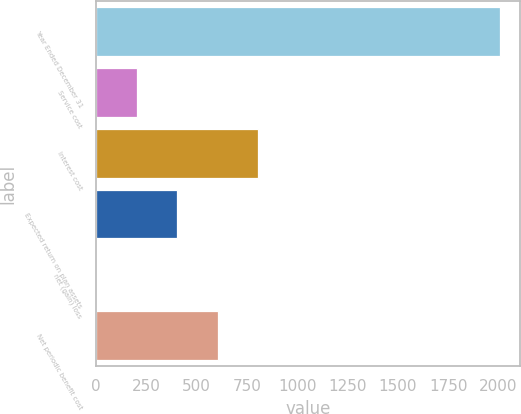<chart> <loc_0><loc_0><loc_500><loc_500><bar_chart><fcel>Year Ended December 31<fcel>Service cost<fcel>Interest cost<fcel>Expected return on plan assets<fcel>net (gain) loss<fcel>Net periodic benefit cost<nl><fcel>2008<fcel>201.7<fcel>803.8<fcel>402.4<fcel>1<fcel>603.1<nl></chart> 